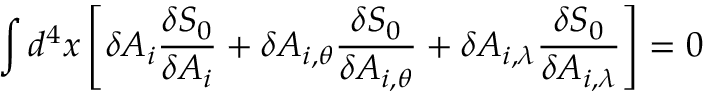<formula> <loc_0><loc_0><loc_500><loc_500>\int d ^ { 4 } x \left [ \delta A _ { i } \frac { \delta S _ { 0 } } { \delta A _ { i } } + \delta A _ { i , \theta } \frac { \delta S _ { 0 } } { \delta A _ { i , \theta } } + \delta A _ { i , \lambda } \frac { \delta S _ { 0 } } { \delta A _ { i , \lambda } } \right ] = 0</formula> 